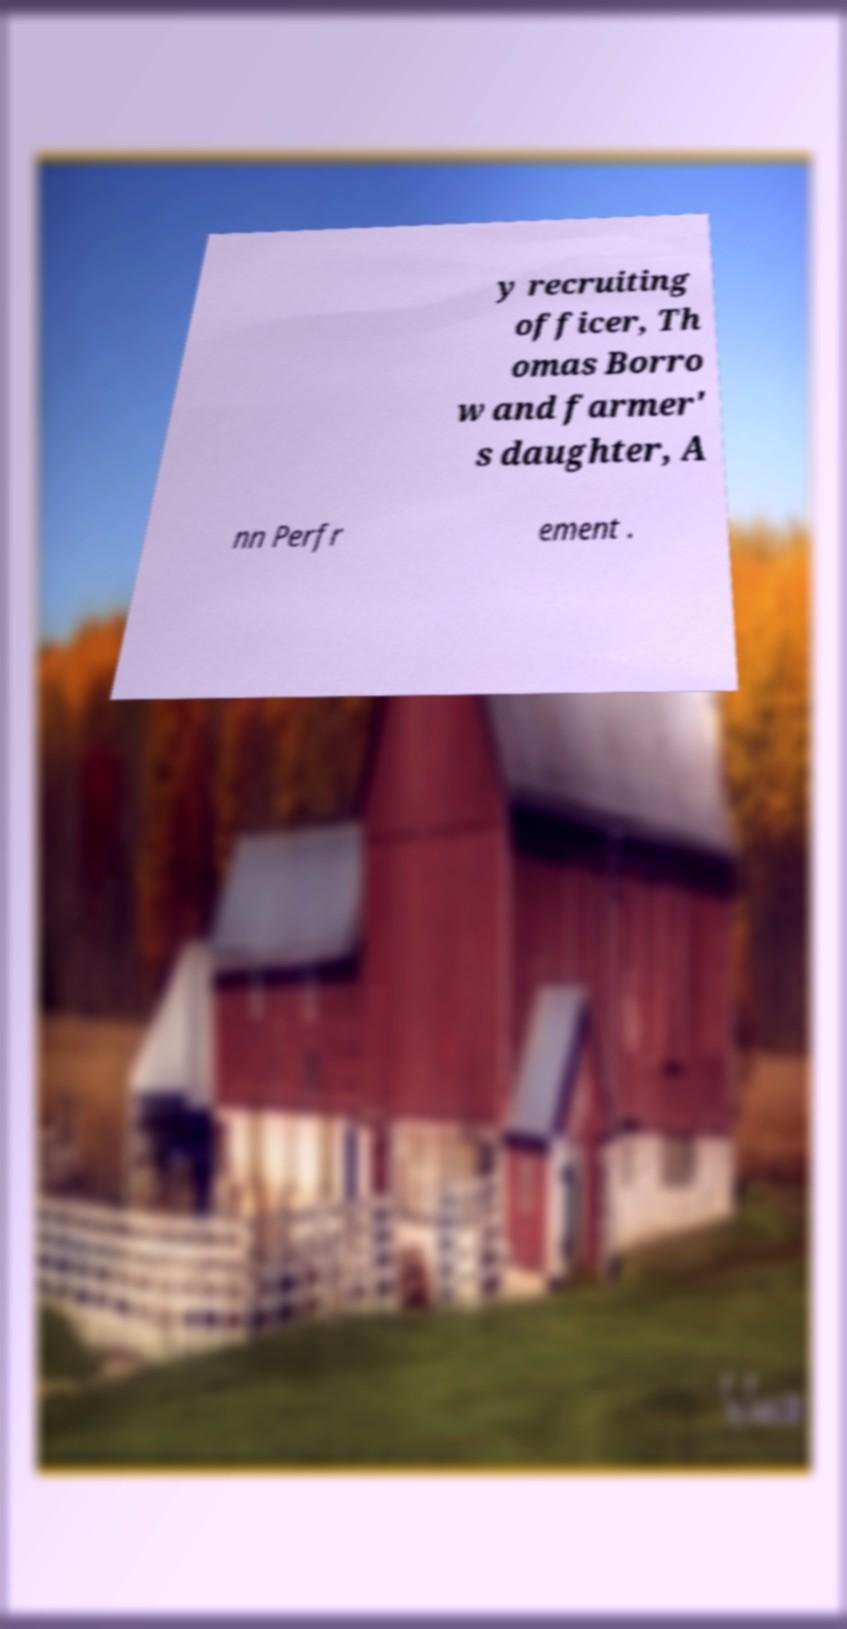I need the written content from this picture converted into text. Can you do that? y recruiting officer, Th omas Borro w and farmer' s daughter, A nn Perfr ement . 